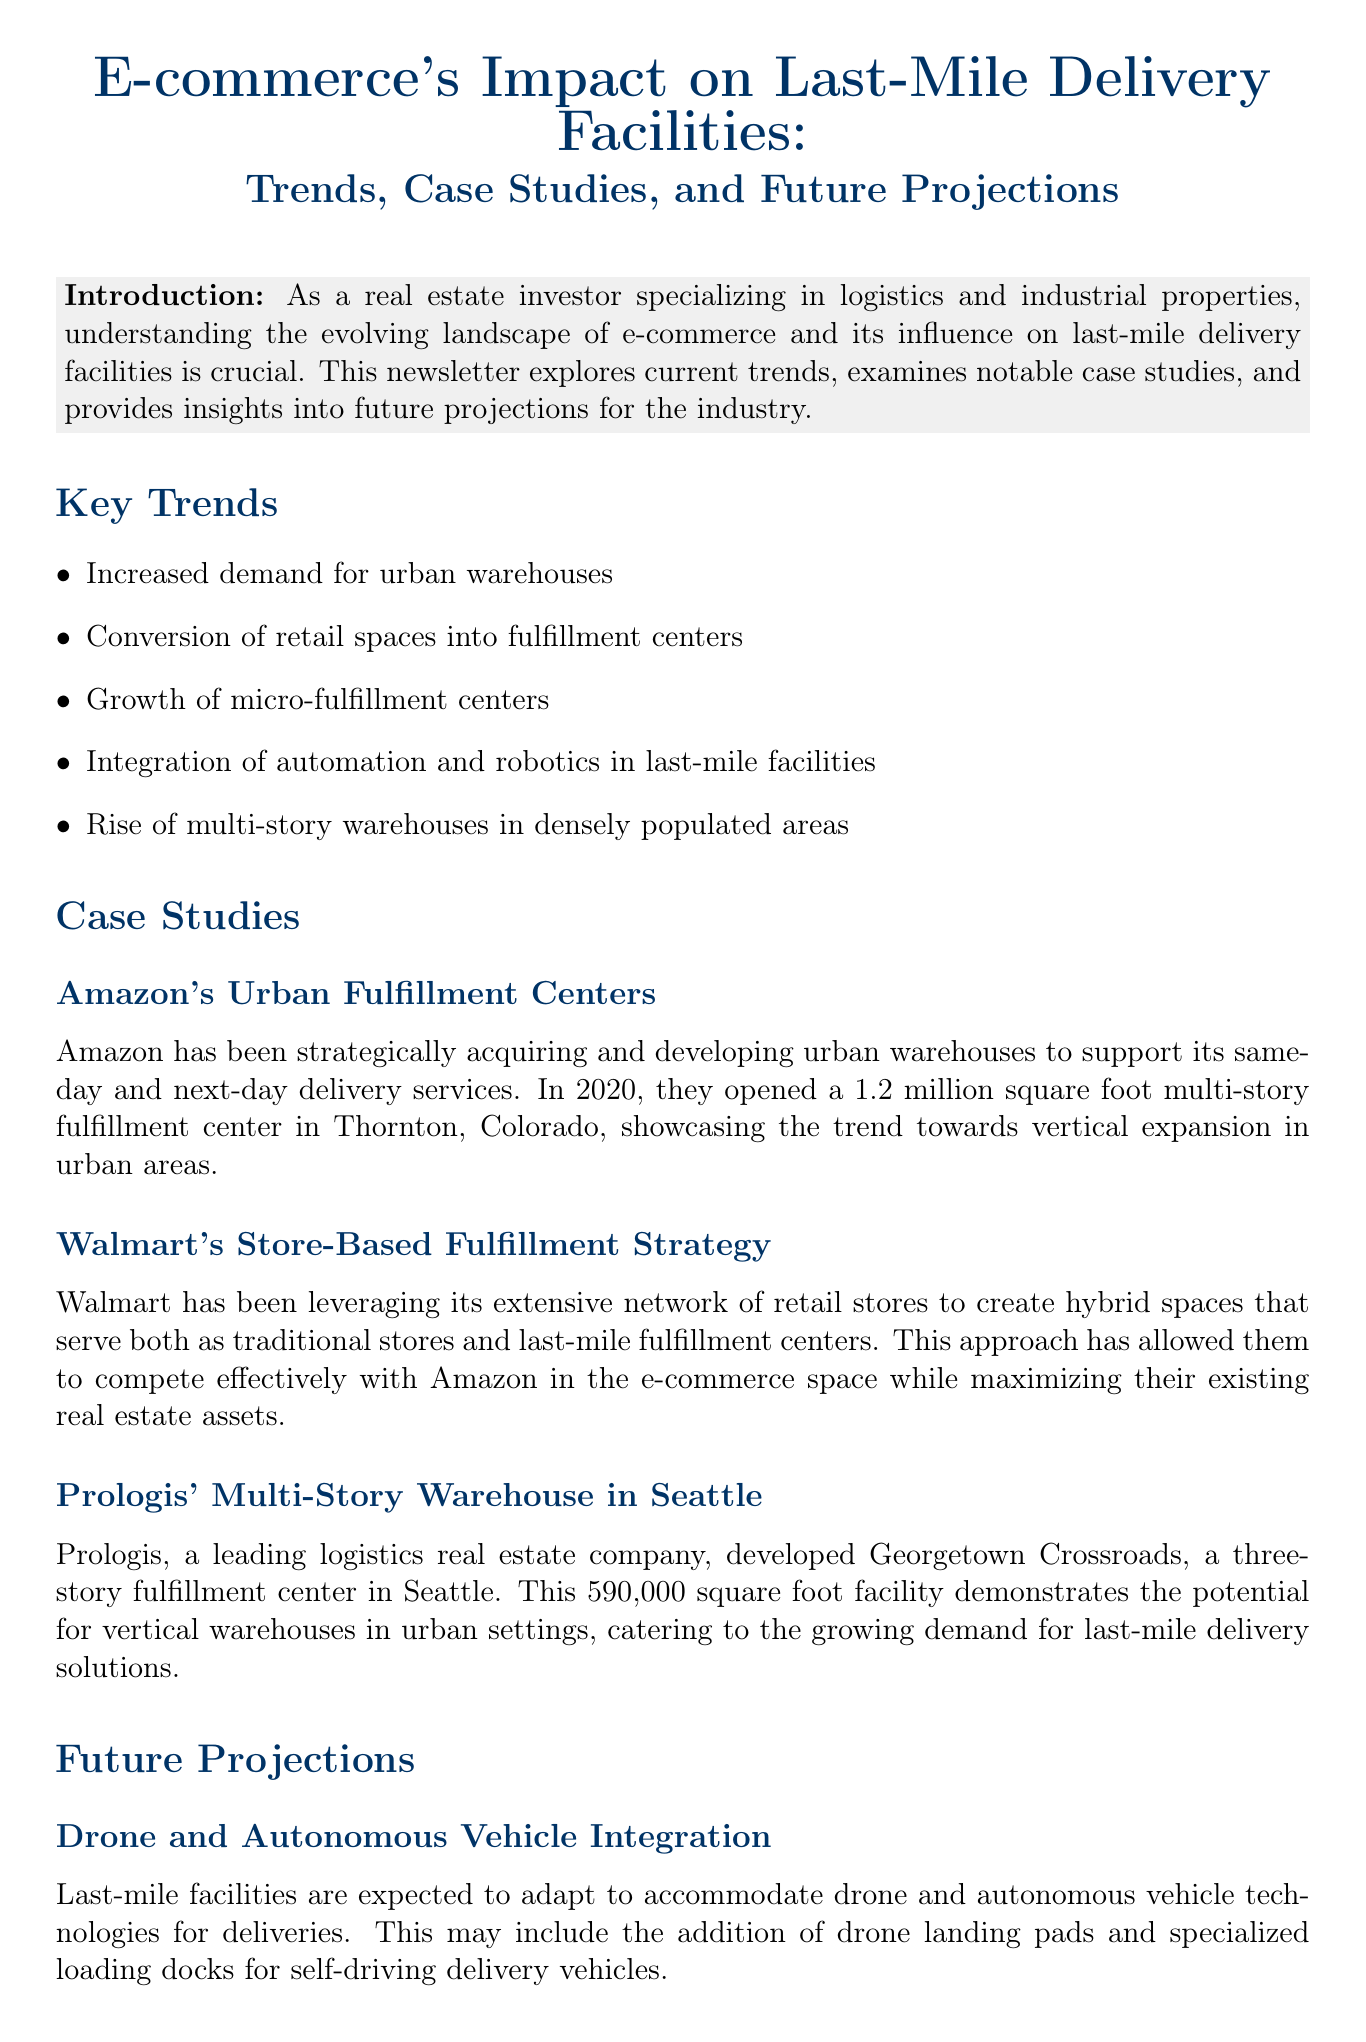what is the title of the newsletter? The title is directly stated at the beginning of the document.
Answer: E-commerce's Impact on Last-Mile Delivery Facilities: Trends, Case Studies, and Future Projections how many key trends are listed in the document? The number of key trends provided is found in the "Key Trends" section as bullet points.
Answer: 5 what is the size of Amazon's multi-story fulfillment center in Thornton, Colorado? The size is mentioned in the case study about Amazon's Urban Fulfillment Centers.
Answer: 1.2 million square foot which company developed a three-story fulfillment center in Seattle? The company responsible for developing the fulfillment center is specified in the respective case study.
Answer: Prologis which trend involves the adaptation of drone technologies? The specific trend that mentions drone technologies is found in the "Future Projections" section.
Answer: Drone and Autonomous Vehicle Integration what kind of facilities are expected to include automated micro-fulfillment units? The type of facilities that are expected to have these units is noted in the description of a specific future trend.
Answer: Hyper-Local Micro-Fulfillment Centers what strategic approach does Walmart use for its fulfillment centers? The strategy used by Walmart is explained in the context of its store-based fulfillment strategy.
Answer: Hybrid spaces which investment opportunity pertains to properties suitable for micro-fulfillment networks? The specific investment opportunity related to micro-fulfillment centers is listed under the "Investment Opportunities" section.
Answer: Investment in properties suitable for micro-fulfillment center networks 